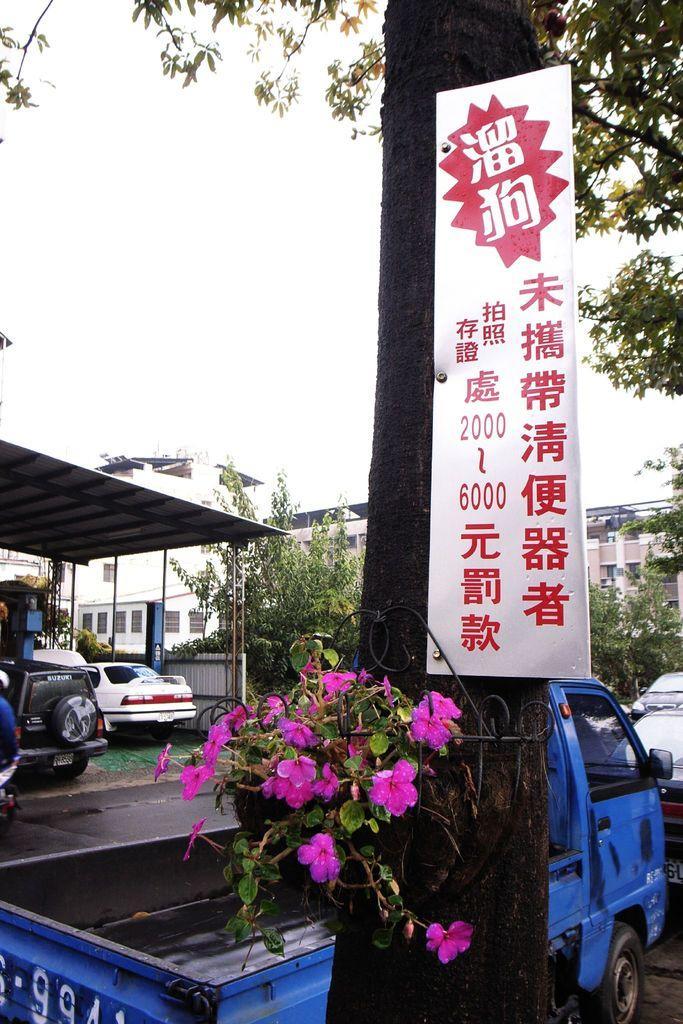Could you give a brief overview of what you see in this image? In this image I can see a white board, pink flowers and vehicles on the road. There is a shed on the left. There are trees and buildings at the back. 